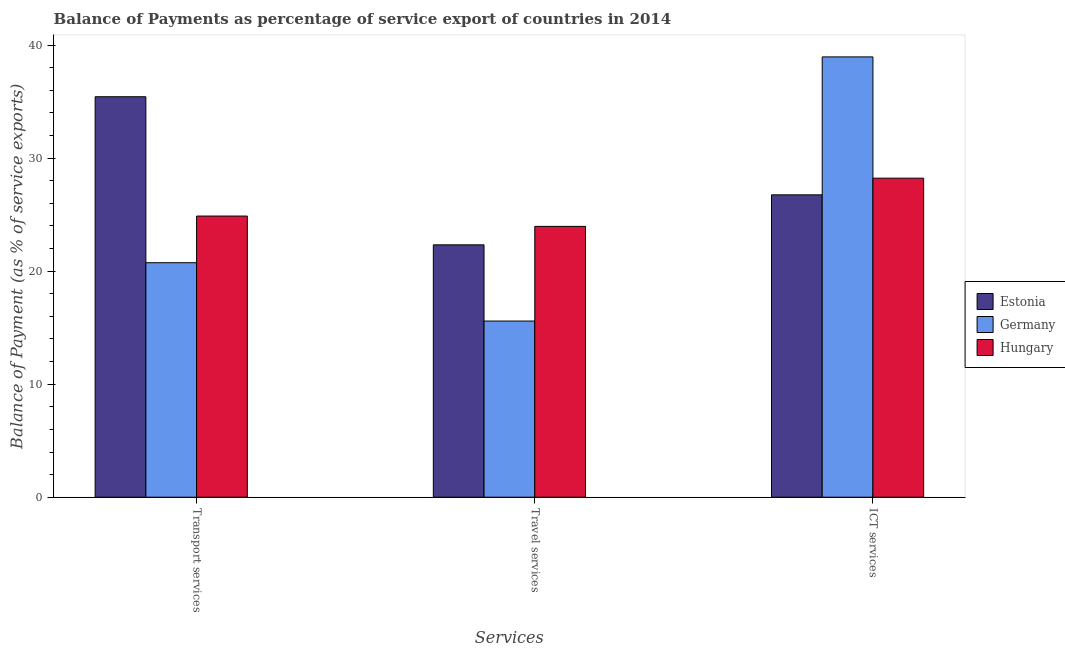How many different coloured bars are there?
Keep it short and to the point. 3. How many groups of bars are there?
Make the answer very short. 3. How many bars are there on the 3rd tick from the left?
Make the answer very short. 3. What is the label of the 2nd group of bars from the left?
Offer a terse response. Travel services. What is the balance of payment of travel services in Hungary?
Provide a short and direct response. 23.96. Across all countries, what is the maximum balance of payment of ict services?
Your response must be concise. 38.96. Across all countries, what is the minimum balance of payment of transport services?
Ensure brevity in your answer.  20.75. In which country was the balance of payment of travel services maximum?
Make the answer very short. Hungary. What is the total balance of payment of ict services in the graph?
Offer a terse response. 93.93. What is the difference between the balance of payment of transport services in Germany and that in Estonia?
Offer a terse response. -14.68. What is the difference between the balance of payment of transport services in Hungary and the balance of payment of travel services in Germany?
Provide a succinct answer. 9.29. What is the average balance of payment of travel services per country?
Make the answer very short. 20.62. What is the difference between the balance of payment of ict services and balance of payment of travel services in Germany?
Your answer should be compact. 23.37. In how many countries, is the balance of payment of ict services greater than 10 %?
Make the answer very short. 3. What is the ratio of the balance of payment of transport services in Germany to that in Hungary?
Keep it short and to the point. 0.83. Is the balance of payment of transport services in Estonia less than that in Hungary?
Provide a short and direct response. No. What is the difference between the highest and the second highest balance of payment of travel services?
Give a very brief answer. 1.63. What is the difference between the highest and the lowest balance of payment of transport services?
Offer a terse response. 14.68. What does the 3rd bar from the left in Transport services represents?
Give a very brief answer. Hungary. What does the 1st bar from the right in Transport services represents?
Make the answer very short. Hungary. How many bars are there?
Provide a succinct answer. 9. How many countries are there in the graph?
Give a very brief answer. 3. What is the difference between two consecutive major ticks on the Y-axis?
Keep it short and to the point. 10. Are the values on the major ticks of Y-axis written in scientific E-notation?
Your answer should be very brief. No. Does the graph contain any zero values?
Provide a succinct answer. No. Does the graph contain grids?
Provide a succinct answer. No. How many legend labels are there?
Give a very brief answer. 3. How are the legend labels stacked?
Ensure brevity in your answer.  Vertical. What is the title of the graph?
Your answer should be very brief. Balance of Payments as percentage of service export of countries in 2014. Does "France" appear as one of the legend labels in the graph?
Your answer should be compact. No. What is the label or title of the X-axis?
Ensure brevity in your answer.  Services. What is the label or title of the Y-axis?
Keep it short and to the point. Balance of Payment (as % of service exports). What is the Balance of Payment (as % of service exports) of Estonia in Transport services?
Provide a succinct answer. 35.43. What is the Balance of Payment (as % of service exports) of Germany in Transport services?
Offer a very short reply. 20.75. What is the Balance of Payment (as % of service exports) in Hungary in Transport services?
Your answer should be very brief. 24.87. What is the Balance of Payment (as % of service exports) in Estonia in Travel services?
Your answer should be compact. 22.33. What is the Balance of Payment (as % of service exports) of Germany in Travel services?
Make the answer very short. 15.59. What is the Balance of Payment (as % of service exports) in Hungary in Travel services?
Your answer should be very brief. 23.96. What is the Balance of Payment (as % of service exports) of Estonia in ICT services?
Your answer should be very brief. 26.75. What is the Balance of Payment (as % of service exports) in Germany in ICT services?
Ensure brevity in your answer.  38.96. What is the Balance of Payment (as % of service exports) in Hungary in ICT services?
Offer a terse response. 28.22. Across all Services, what is the maximum Balance of Payment (as % of service exports) in Estonia?
Provide a short and direct response. 35.43. Across all Services, what is the maximum Balance of Payment (as % of service exports) in Germany?
Give a very brief answer. 38.96. Across all Services, what is the maximum Balance of Payment (as % of service exports) of Hungary?
Offer a terse response. 28.22. Across all Services, what is the minimum Balance of Payment (as % of service exports) in Estonia?
Provide a succinct answer. 22.33. Across all Services, what is the minimum Balance of Payment (as % of service exports) of Germany?
Keep it short and to the point. 15.59. Across all Services, what is the minimum Balance of Payment (as % of service exports) of Hungary?
Make the answer very short. 23.96. What is the total Balance of Payment (as % of service exports) of Estonia in the graph?
Your answer should be very brief. 84.51. What is the total Balance of Payment (as % of service exports) of Germany in the graph?
Keep it short and to the point. 75.29. What is the total Balance of Payment (as % of service exports) of Hungary in the graph?
Provide a short and direct response. 77.06. What is the difference between the Balance of Payment (as % of service exports) in Estonia in Transport services and that in Travel services?
Give a very brief answer. 13.1. What is the difference between the Balance of Payment (as % of service exports) of Germany in Transport services and that in Travel services?
Your answer should be very brief. 5.16. What is the difference between the Balance of Payment (as % of service exports) in Hungary in Transport services and that in Travel services?
Your answer should be compact. 0.91. What is the difference between the Balance of Payment (as % of service exports) in Estonia in Transport services and that in ICT services?
Keep it short and to the point. 8.68. What is the difference between the Balance of Payment (as % of service exports) of Germany in Transport services and that in ICT services?
Your response must be concise. -18.21. What is the difference between the Balance of Payment (as % of service exports) in Hungary in Transport services and that in ICT services?
Your response must be concise. -3.35. What is the difference between the Balance of Payment (as % of service exports) of Estonia in Travel services and that in ICT services?
Give a very brief answer. -4.42. What is the difference between the Balance of Payment (as % of service exports) in Germany in Travel services and that in ICT services?
Offer a very short reply. -23.37. What is the difference between the Balance of Payment (as % of service exports) of Hungary in Travel services and that in ICT services?
Give a very brief answer. -4.26. What is the difference between the Balance of Payment (as % of service exports) of Estonia in Transport services and the Balance of Payment (as % of service exports) of Germany in Travel services?
Your answer should be compact. 19.84. What is the difference between the Balance of Payment (as % of service exports) in Estonia in Transport services and the Balance of Payment (as % of service exports) in Hungary in Travel services?
Offer a very short reply. 11.47. What is the difference between the Balance of Payment (as % of service exports) of Germany in Transport services and the Balance of Payment (as % of service exports) of Hungary in Travel services?
Make the answer very short. -3.21. What is the difference between the Balance of Payment (as % of service exports) in Estonia in Transport services and the Balance of Payment (as % of service exports) in Germany in ICT services?
Make the answer very short. -3.53. What is the difference between the Balance of Payment (as % of service exports) in Estonia in Transport services and the Balance of Payment (as % of service exports) in Hungary in ICT services?
Make the answer very short. 7.21. What is the difference between the Balance of Payment (as % of service exports) of Germany in Transport services and the Balance of Payment (as % of service exports) of Hungary in ICT services?
Your answer should be very brief. -7.48. What is the difference between the Balance of Payment (as % of service exports) of Estonia in Travel services and the Balance of Payment (as % of service exports) of Germany in ICT services?
Provide a succinct answer. -16.63. What is the difference between the Balance of Payment (as % of service exports) in Estonia in Travel services and the Balance of Payment (as % of service exports) in Hungary in ICT services?
Your answer should be compact. -5.9. What is the difference between the Balance of Payment (as % of service exports) in Germany in Travel services and the Balance of Payment (as % of service exports) in Hungary in ICT services?
Offer a very short reply. -12.64. What is the average Balance of Payment (as % of service exports) in Estonia per Services?
Provide a short and direct response. 28.17. What is the average Balance of Payment (as % of service exports) of Germany per Services?
Keep it short and to the point. 25.1. What is the average Balance of Payment (as % of service exports) of Hungary per Services?
Offer a very short reply. 25.69. What is the difference between the Balance of Payment (as % of service exports) of Estonia and Balance of Payment (as % of service exports) of Germany in Transport services?
Your answer should be very brief. 14.68. What is the difference between the Balance of Payment (as % of service exports) in Estonia and Balance of Payment (as % of service exports) in Hungary in Transport services?
Give a very brief answer. 10.56. What is the difference between the Balance of Payment (as % of service exports) of Germany and Balance of Payment (as % of service exports) of Hungary in Transport services?
Give a very brief answer. -4.13. What is the difference between the Balance of Payment (as % of service exports) of Estonia and Balance of Payment (as % of service exports) of Germany in Travel services?
Give a very brief answer. 6.74. What is the difference between the Balance of Payment (as % of service exports) in Estonia and Balance of Payment (as % of service exports) in Hungary in Travel services?
Provide a short and direct response. -1.63. What is the difference between the Balance of Payment (as % of service exports) of Germany and Balance of Payment (as % of service exports) of Hungary in Travel services?
Provide a short and direct response. -8.37. What is the difference between the Balance of Payment (as % of service exports) of Estonia and Balance of Payment (as % of service exports) of Germany in ICT services?
Ensure brevity in your answer.  -12.2. What is the difference between the Balance of Payment (as % of service exports) in Estonia and Balance of Payment (as % of service exports) in Hungary in ICT services?
Your answer should be compact. -1.47. What is the difference between the Balance of Payment (as % of service exports) in Germany and Balance of Payment (as % of service exports) in Hungary in ICT services?
Provide a short and direct response. 10.73. What is the ratio of the Balance of Payment (as % of service exports) of Estonia in Transport services to that in Travel services?
Give a very brief answer. 1.59. What is the ratio of the Balance of Payment (as % of service exports) in Germany in Transport services to that in Travel services?
Offer a terse response. 1.33. What is the ratio of the Balance of Payment (as % of service exports) in Hungary in Transport services to that in Travel services?
Provide a short and direct response. 1.04. What is the ratio of the Balance of Payment (as % of service exports) of Estonia in Transport services to that in ICT services?
Ensure brevity in your answer.  1.32. What is the ratio of the Balance of Payment (as % of service exports) in Germany in Transport services to that in ICT services?
Give a very brief answer. 0.53. What is the ratio of the Balance of Payment (as % of service exports) of Hungary in Transport services to that in ICT services?
Keep it short and to the point. 0.88. What is the ratio of the Balance of Payment (as % of service exports) of Estonia in Travel services to that in ICT services?
Provide a short and direct response. 0.83. What is the ratio of the Balance of Payment (as % of service exports) of Germany in Travel services to that in ICT services?
Provide a short and direct response. 0.4. What is the ratio of the Balance of Payment (as % of service exports) in Hungary in Travel services to that in ICT services?
Ensure brevity in your answer.  0.85. What is the difference between the highest and the second highest Balance of Payment (as % of service exports) of Estonia?
Ensure brevity in your answer.  8.68. What is the difference between the highest and the second highest Balance of Payment (as % of service exports) in Germany?
Your answer should be very brief. 18.21. What is the difference between the highest and the second highest Balance of Payment (as % of service exports) of Hungary?
Provide a succinct answer. 3.35. What is the difference between the highest and the lowest Balance of Payment (as % of service exports) in Estonia?
Provide a short and direct response. 13.1. What is the difference between the highest and the lowest Balance of Payment (as % of service exports) of Germany?
Offer a terse response. 23.37. What is the difference between the highest and the lowest Balance of Payment (as % of service exports) in Hungary?
Make the answer very short. 4.26. 